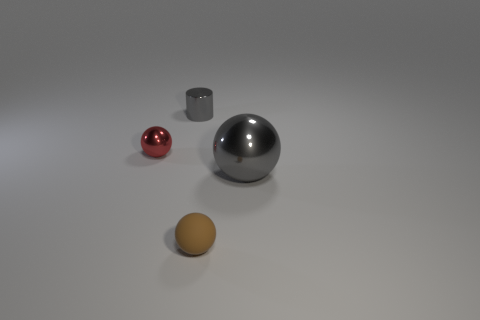Add 2 big gray things. How many objects exist? 6 Subtract all shiny spheres. How many spheres are left? 1 Subtract 2 spheres. How many spheres are left? 1 Subtract all gray cylinders. How many red balls are left? 1 Subtract all brown balls. How many balls are left? 2 Subtract 0 yellow spheres. How many objects are left? 4 Subtract all spheres. How many objects are left? 1 Subtract all red cylinders. Subtract all brown blocks. How many cylinders are left? 1 Subtract all green matte objects. Subtract all tiny brown rubber things. How many objects are left? 3 Add 1 small metal cylinders. How many small metal cylinders are left? 2 